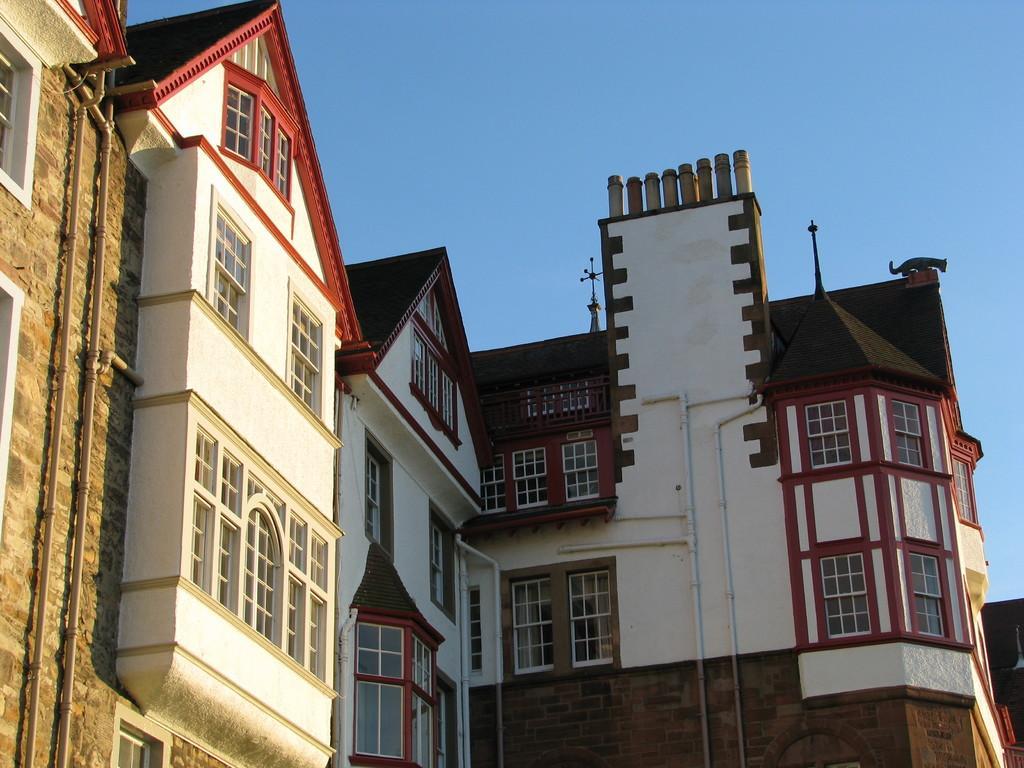Could you give a brief overview of what you see in this image? In this image we can see some buildings which are of similar color red and white and at the top of the image there is sky and there is cat on top of the building. 